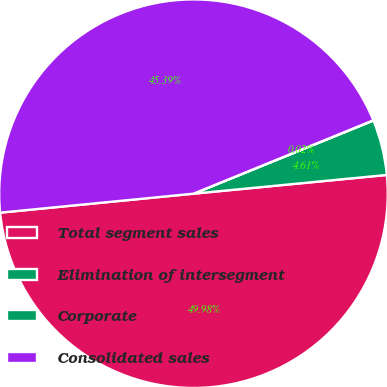Convert chart to OTSL. <chart><loc_0><loc_0><loc_500><loc_500><pie_chart><fcel>Total segment sales<fcel>Elimination of intersegment<fcel>Corporate<fcel>Consolidated sales<nl><fcel>49.98%<fcel>4.61%<fcel>0.02%<fcel>45.39%<nl></chart> 